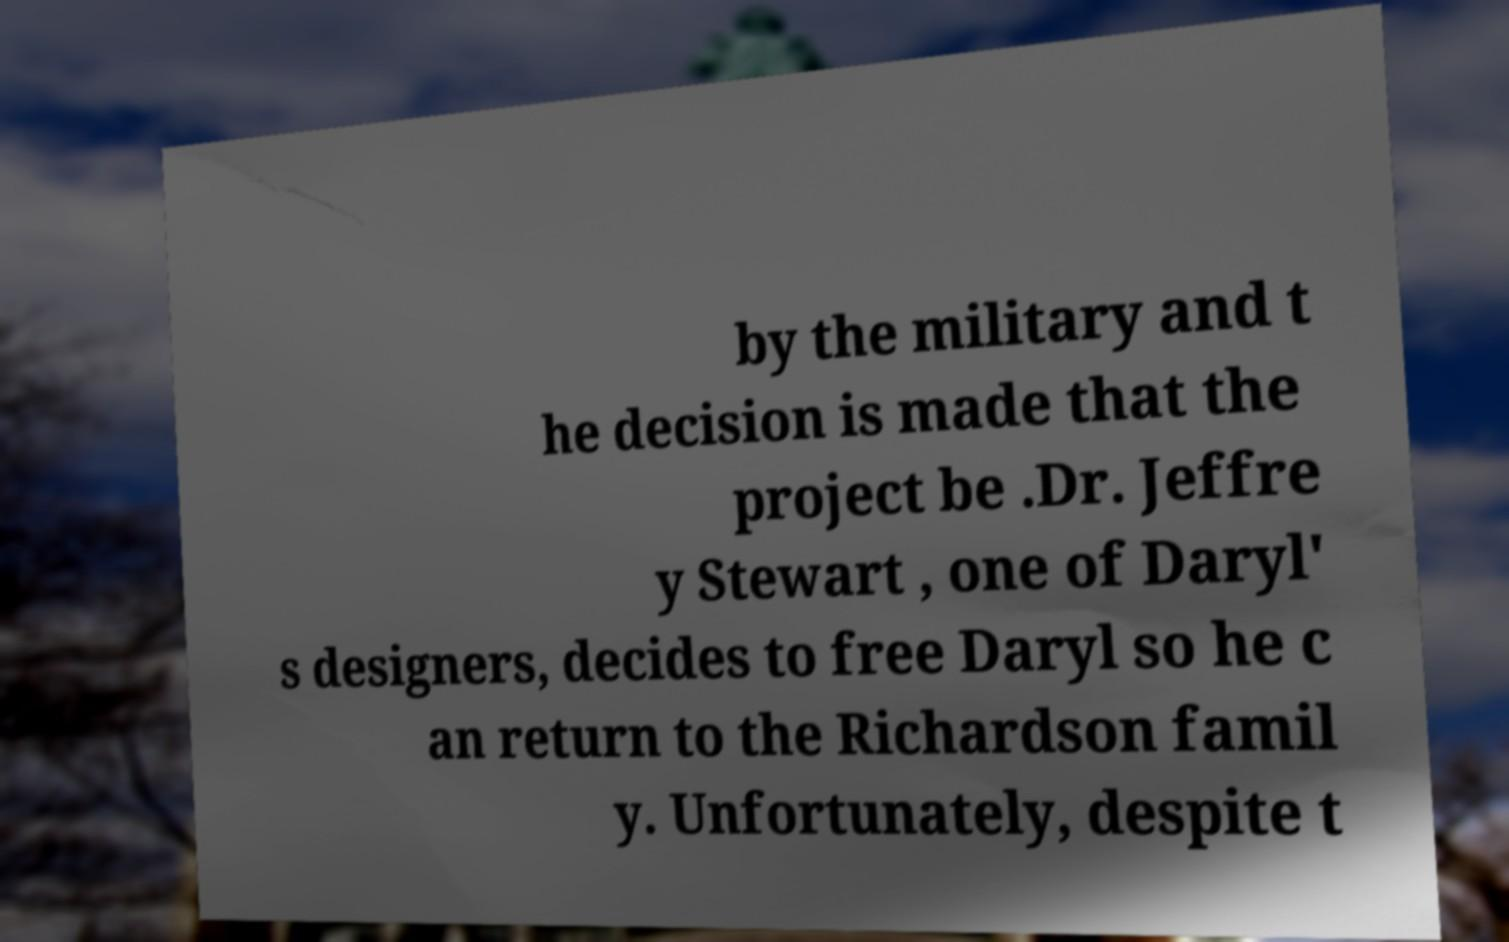There's text embedded in this image that I need extracted. Can you transcribe it verbatim? by the military and t he decision is made that the project be .Dr. Jeffre y Stewart , one of Daryl' s designers, decides to free Daryl so he c an return to the Richardson famil y. Unfortunately, despite t 